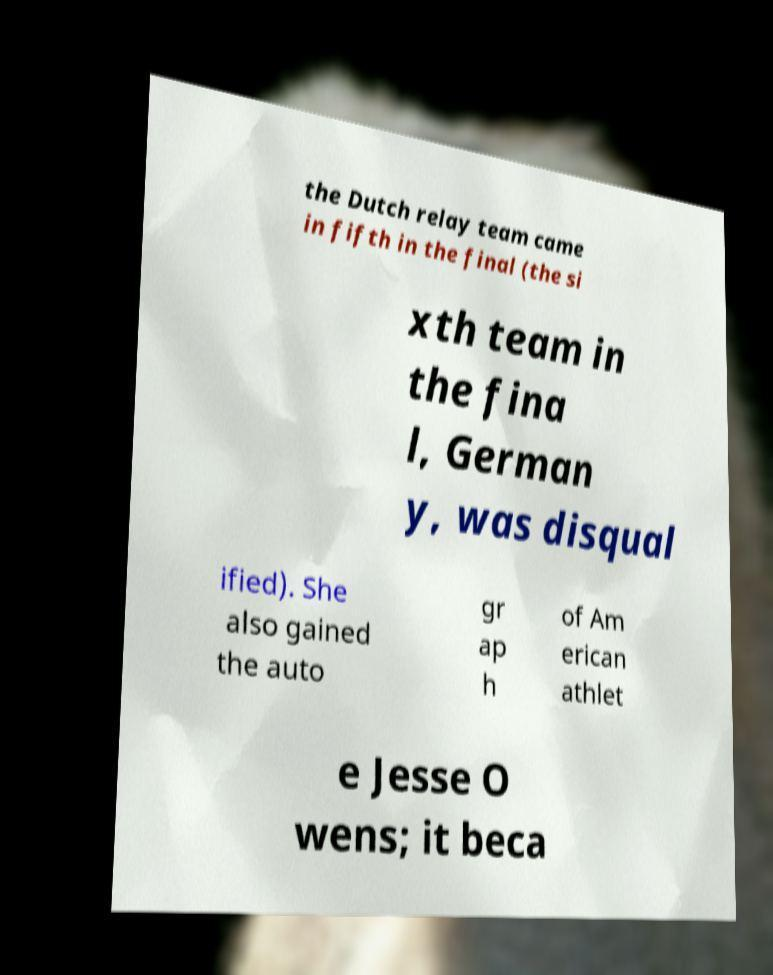I need the written content from this picture converted into text. Can you do that? the Dutch relay team came in fifth in the final (the si xth team in the fina l, German y, was disqual ified). She also gained the auto gr ap h of Am erican athlet e Jesse O wens; it beca 